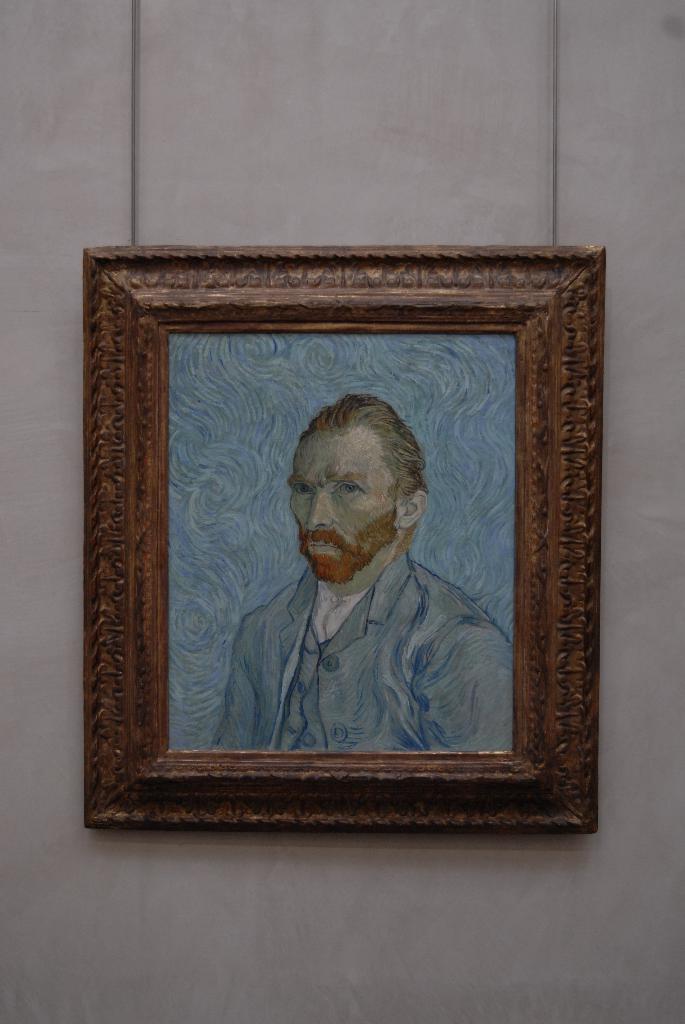Describe this image in one or two sentences. In the center of the image, we can see a frame on the wall and on the board, we can see a sketch of a person. 